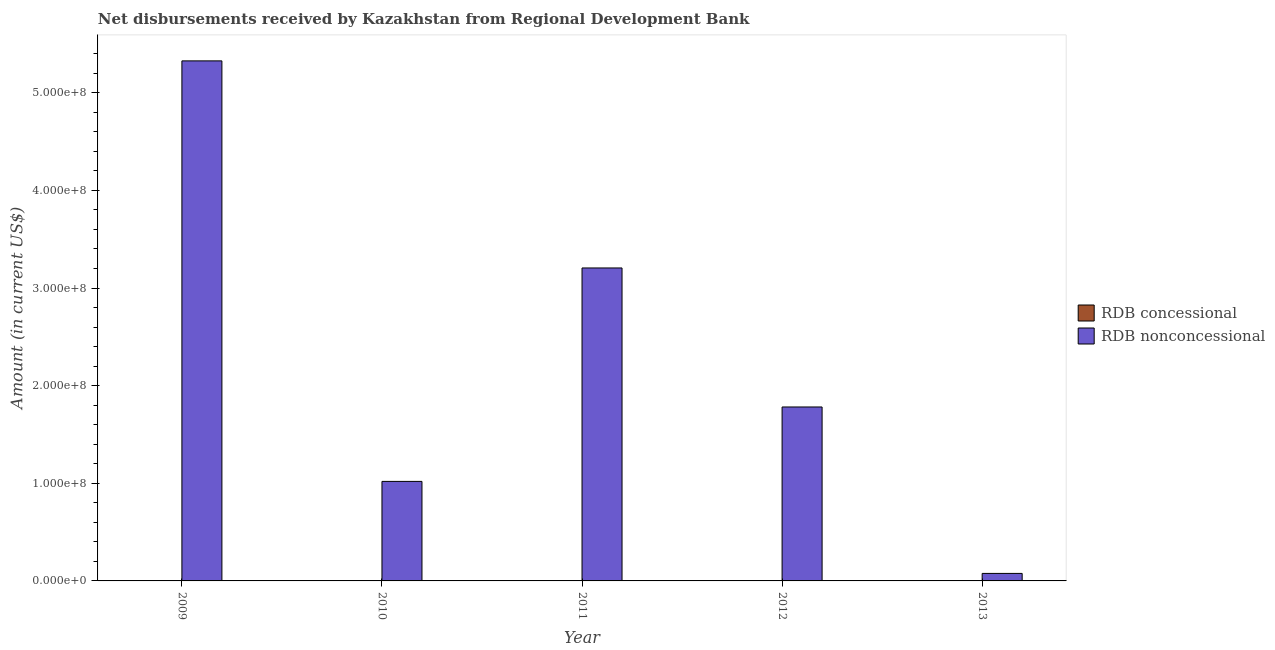Are the number of bars on each tick of the X-axis equal?
Your answer should be compact. Yes. In how many cases, is the number of bars for a given year not equal to the number of legend labels?
Your response must be concise. 5. Across all years, what is the maximum net non concessional disbursements from rdb?
Your answer should be compact. 5.33e+08. Across all years, what is the minimum net non concessional disbursements from rdb?
Keep it short and to the point. 7.69e+06. In which year was the net non concessional disbursements from rdb maximum?
Offer a terse response. 2009. What is the difference between the net non concessional disbursements from rdb in 2012 and that in 2013?
Offer a very short reply. 1.70e+08. What is the difference between the net non concessional disbursements from rdb in 2009 and the net concessional disbursements from rdb in 2013?
Ensure brevity in your answer.  5.25e+08. What is the average net non concessional disbursements from rdb per year?
Make the answer very short. 2.28e+08. In how many years, is the net non concessional disbursements from rdb greater than 100000000 US$?
Ensure brevity in your answer.  4. What is the ratio of the net non concessional disbursements from rdb in 2009 to that in 2010?
Your answer should be very brief. 5.23. Is the net non concessional disbursements from rdb in 2009 less than that in 2012?
Your response must be concise. No. What is the difference between the highest and the second highest net non concessional disbursements from rdb?
Keep it short and to the point. 2.12e+08. What is the difference between the highest and the lowest net non concessional disbursements from rdb?
Offer a very short reply. 5.25e+08. Is the sum of the net non concessional disbursements from rdb in 2009 and 2010 greater than the maximum net concessional disbursements from rdb across all years?
Your answer should be compact. Yes. Are all the bars in the graph horizontal?
Offer a terse response. No. Are the values on the major ticks of Y-axis written in scientific E-notation?
Give a very brief answer. Yes. Does the graph contain any zero values?
Your answer should be compact. Yes. How many legend labels are there?
Your answer should be compact. 2. What is the title of the graph?
Your answer should be very brief. Net disbursements received by Kazakhstan from Regional Development Bank. What is the label or title of the X-axis?
Your response must be concise. Year. What is the Amount (in current US$) in RDB nonconcessional in 2009?
Your answer should be compact. 5.33e+08. What is the Amount (in current US$) in RDB concessional in 2010?
Keep it short and to the point. 0. What is the Amount (in current US$) in RDB nonconcessional in 2010?
Provide a succinct answer. 1.02e+08. What is the Amount (in current US$) of RDB nonconcessional in 2011?
Give a very brief answer. 3.21e+08. What is the Amount (in current US$) in RDB nonconcessional in 2012?
Provide a succinct answer. 1.78e+08. What is the Amount (in current US$) in RDB concessional in 2013?
Give a very brief answer. 0. What is the Amount (in current US$) in RDB nonconcessional in 2013?
Offer a very short reply. 7.69e+06. Across all years, what is the maximum Amount (in current US$) of RDB nonconcessional?
Keep it short and to the point. 5.33e+08. Across all years, what is the minimum Amount (in current US$) in RDB nonconcessional?
Your answer should be very brief. 7.69e+06. What is the total Amount (in current US$) in RDB concessional in the graph?
Your answer should be very brief. 0. What is the total Amount (in current US$) in RDB nonconcessional in the graph?
Your answer should be compact. 1.14e+09. What is the difference between the Amount (in current US$) of RDB nonconcessional in 2009 and that in 2010?
Provide a succinct answer. 4.31e+08. What is the difference between the Amount (in current US$) in RDB nonconcessional in 2009 and that in 2011?
Offer a terse response. 2.12e+08. What is the difference between the Amount (in current US$) of RDB nonconcessional in 2009 and that in 2012?
Offer a very short reply. 3.54e+08. What is the difference between the Amount (in current US$) of RDB nonconcessional in 2009 and that in 2013?
Your response must be concise. 5.25e+08. What is the difference between the Amount (in current US$) in RDB nonconcessional in 2010 and that in 2011?
Make the answer very short. -2.19e+08. What is the difference between the Amount (in current US$) of RDB nonconcessional in 2010 and that in 2012?
Provide a succinct answer. -7.62e+07. What is the difference between the Amount (in current US$) in RDB nonconcessional in 2010 and that in 2013?
Give a very brief answer. 9.42e+07. What is the difference between the Amount (in current US$) in RDB nonconcessional in 2011 and that in 2012?
Offer a terse response. 1.42e+08. What is the difference between the Amount (in current US$) of RDB nonconcessional in 2011 and that in 2013?
Your answer should be compact. 3.13e+08. What is the difference between the Amount (in current US$) of RDB nonconcessional in 2012 and that in 2013?
Your answer should be very brief. 1.70e+08. What is the average Amount (in current US$) of RDB concessional per year?
Provide a short and direct response. 0. What is the average Amount (in current US$) of RDB nonconcessional per year?
Your answer should be very brief. 2.28e+08. What is the ratio of the Amount (in current US$) of RDB nonconcessional in 2009 to that in 2010?
Keep it short and to the point. 5.23. What is the ratio of the Amount (in current US$) of RDB nonconcessional in 2009 to that in 2011?
Your response must be concise. 1.66. What is the ratio of the Amount (in current US$) of RDB nonconcessional in 2009 to that in 2012?
Offer a terse response. 2.99. What is the ratio of the Amount (in current US$) in RDB nonconcessional in 2009 to that in 2013?
Keep it short and to the point. 69.28. What is the ratio of the Amount (in current US$) of RDB nonconcessional in 2010 to that in 2011?
Offer a very short reply. 0.32. What is the ratio of the Amount (in current US$) of RDB nonconcessional in 2010 to that in 2012?
Offer a very short reply. 0.57. What is the ratio of the Amount (in current US$) of RDB nonconcessional in 2010 to that in 2013?
Provide a succinct answer. 13.26. What is the ratio of the Amount (in current US$) of RDB nonconcessional in 2011 to that in 2012?
Ensure brevity in your answer.  1.8. What is the ratio of the Amount (in current US$) of RDB nonconcessional in 2011 to that in 2013?
Offer a very short reply. 41.69. What is the ratio of the Amount (in current US$) in RDB nonconcessional in 2012 to that in 2013?
Your response must be concise. 23.17. What is the difference between the highest and the second highest Amount (in current US$) of RDB nonconcessional?
Offer a terse response. 2.12e+08. What is the difference between the highest and the lowest Amount (in current US$) in RDB nonconcessional?
Give a very brief answer. 5.25e+08. 